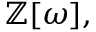<formula> <loc_0><loc_0><loc_500><loc_500>\mathbb { Z } [ \omega ] ,</formula> 